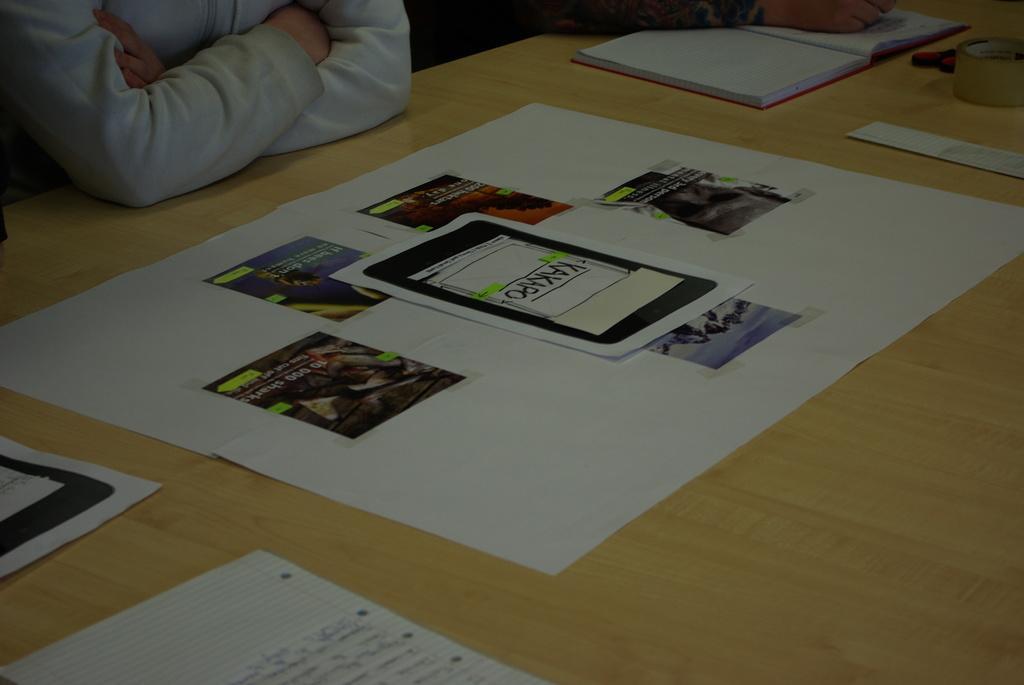Please provide a concise description of this image. In this picture we have some group of papers stick to another paper in the table and there is a book, tape and scissors in the table and at back ground we have some persons. 